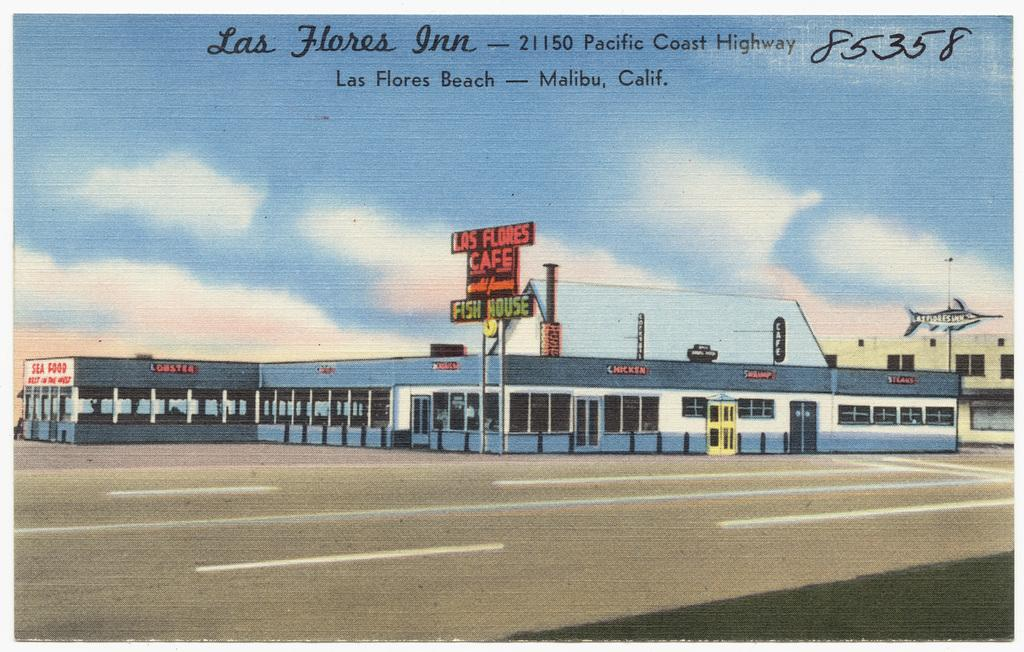What is the main subject of the image? The image contains a picture. What can be seen in the sky in the picture? The sky with clouds can be seen in the picture. What type of commercial signs are present in the image? There are advertisement boards in the picture. How many buildings are visible in the image? There is at least one building in the picture. What type of pathway is present in the image? There is a road in the picture. What structure can be seen emitting smoke in the image? There is a chimney in the picture. What time of day is it in the image, and can you see a goose walking on the road? The time of day is not mentioned in the image, and there is no goose present on the road. Is there a horse-drawn carriage visible in the image? There is no horse-drawn carriage present in the image. 